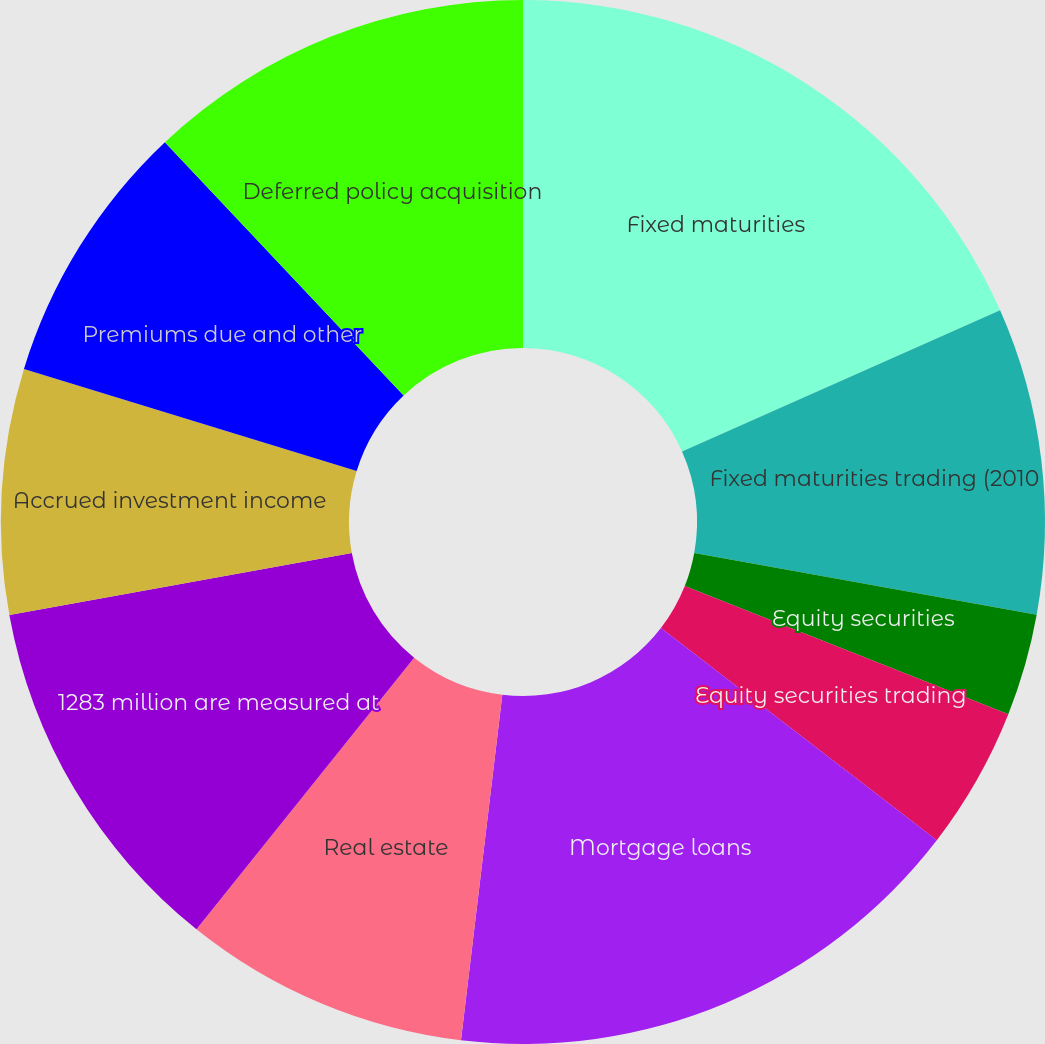Convert chart. <chart><loc_0><loc_0><loc_500><loc_500><pie_chart><fcel>Fixed maturities<fcel>Fixed maturities trading (2010<fcel>Equity securities<fcel>Equity securities trading<fcel>Mortgage loans<fcel>Real estate<fcel>1283 million are measured at<fcel>Accrued investment income<fcel>Premiums due and other<fcel>Deferred policy acquisition<nl><fcel>18.35%<fcel>9.49%<fcel>3.16%<fcel>4.43%<fcel>16.46%<fcel>8.86%<fcel>11.39%<fcel>7.59%<fcel>8.23%<fcel>12.03%<nl></chart> 